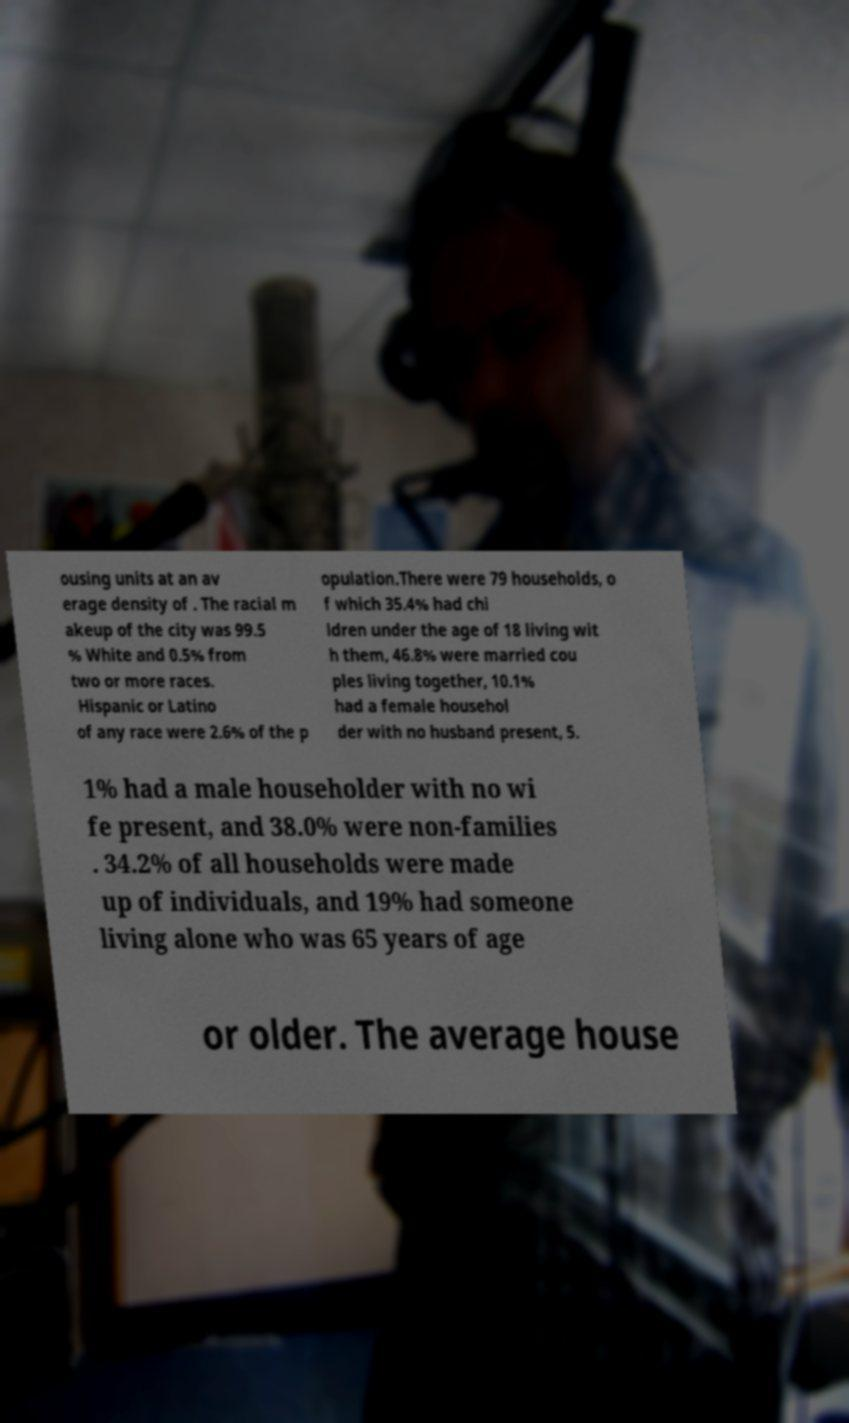What messages or text are displayed in this image? I need them in a readable, typed format. ousing units at an av erage density of . The racial m akeup of the city was 99.5 % White and 0.5% from two or more races. Hispanic or Latino of any race were 2.6% of the p opulation.There were 79 households, o f which 35.4% had chi ldren under the age of 18 living wit h them, 46.8% were married cou ples living together, 10.1% had a female househol der with no husband present, 5. 1% had a male householder with no wi fe present, and 38.0% were non-families . 34.2% of all households were made up of individuals, and 19% had someone living alone who was 65 years of age or older. The average house 